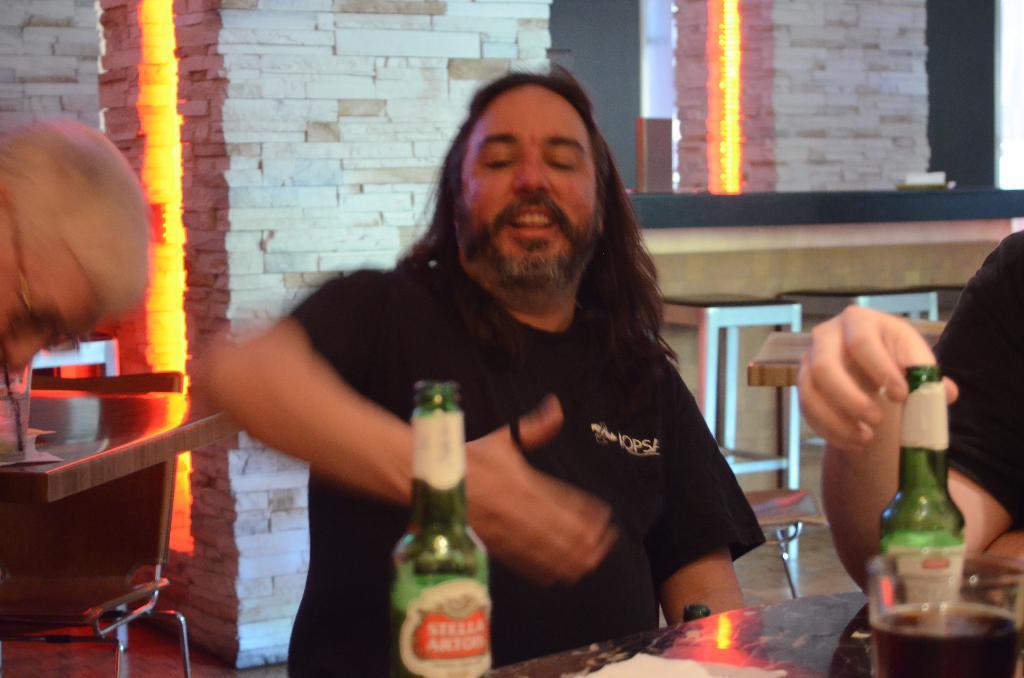Could you give a brief overview of what you see in this image? In the image we can see there is a person who is in front wearing black colour shirt and infront we can see there are wine bottles which are kept on the table along with the wine glass and there are people who are beside the person and at the back there is wall which is of marbles and at the back there are tables and chairs. 